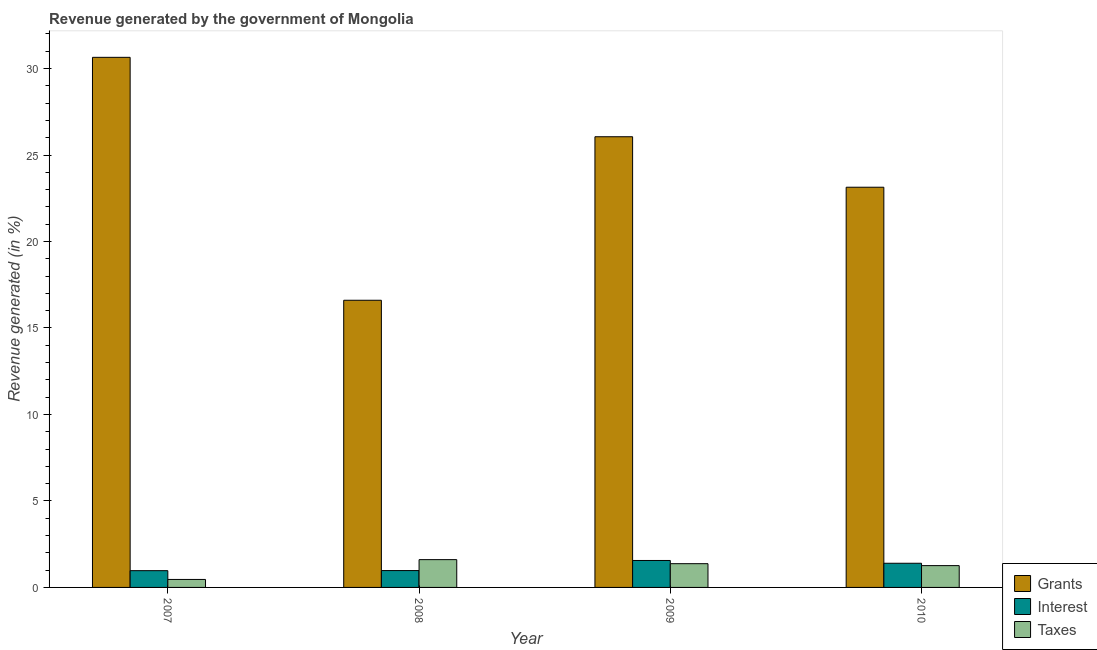How many groups of bars are there?
Provide a succinct answer. 4. Are the number of bars per tick equal to the number of legend labels?
Make the answer very short. Yes. How many bars are there on the 3rd tick from the right?
Keep it short and to the point. 3. What is the percentage of revenue generated by grants in 2007?
Ensure brevity in your answer.  30.65. Across all years, what is the maximum percentage of revenue generated by interest?
Your answer should be very brief. 1.56. Across all years, what is the minimum percentage of revenue generated by interest?
Ensure brevity in your answer.  0.97. In which year was the percentage of revenue generated by grants maximum?
Your response must be concise. 2007. What is the total percentage of revenue generated by interest in the graph?
Your answer should be very brief. 4.9. What is the difference between the percentage of revenue generated by grants in 2009 and that in 2010?
Your response must be concise. 2.92. What is the difference between the percentage of revenue generated by interest in 2008 and the percentage of revenue generated by grants in 2009?
Your response must be concise. -0.58. What is the average percentage of revenue generated by taxes per year?
Your answer should be compact. 1.18. In how many years, is the percentage of revenue generated by interest greater than 4 %?
Make the answer very short. 0. What is the ratio of the percentage of revenue generated by taxes in 2009 to that in 2010?
Offer a terse response. 1.09. Is the difference between the percentage of revenue generated by taxes in 2008 and 2010 greater than the difference between the percentage of revenue generated by grants in 2008 and 2010?
Provide a short and direct response. No. What is the difference between the highest and the second highest percentage of revenue generated by grants?
Provide a succinct answer. 4.59. What is the difference between the highest and the lowest percentage of revenue generated by taxes?
Make the answer very short. 1.15. In how many years, is the percentage of revenue generated by taxes greater than the average percentage of revenue generated by taxes taken over all years?
Offer a very short reply. 3. What does the 2nd bar from the left in 2008 represents?
Make the answer very short. Interest. What does the 1st bar from the right in 2008 represents?
Keep it short and to the point. Taxes. How many bars are there?
Your answer should be compact. 12. Are the values on the major ticks of Y-axis written in scientific E-notation?
Provide a short and direct response. No. Does the graph contain any zero values?
Your answer should be compact. No. Does the graph contain grids?
Provide a succinct answer. No. How many legend labels are there?
Offer a terse response. 3. How are the legend labels stacked?
Your response must be concise. Vertical. What is the title of the graph?
Offer a terse response. Revenue generated by the government of Mongolia. Does "Poland" appear as one of the legend labels in the graph?
Provide a short and direct response. No. What is the label or title of the Y-axis?
Your answer should be compact. Revenue generated (in %). What is the Revenue generated (in %) of Grants in 2007?
Provide a short and direct response. 30.65. What is the Revenue generated (in %) of Interest in 2007?
Give a very brief answer. 0.97. What is the Revenue generated (in %) of Taxes in 2007?
Offer a very short reply. 0.46. What is the Revenue generated (in %) of Grants in 2008?
Ensure brevity in your answer.  16.6. What is the Revenue generated (in %) in Interest in 2008?
Your response must be concise. 0.97. What is the Revenue generated (in %) in Taxes in 2008?
Make the answer very short. 1.61. What is the Revenue generated (in %) in Grants in 2009?
Ensure brevity in your answer.  26.06. What is the Revenue generated (in %) of Interest in 2009?
Your answer should be compact. 1.56. What is the Revenue generated (in %) of Taxes in 2009?
Your answer should be very brief. 1.37. What is the Revenue generated (in %) of Grants in 2010?
Your answer should be very brief. 23.14. What is the Revenue generated (in %) of Interest in 2010?
Ensure brevity in your answer.  1.4. What is the Revenue generated (in %) in Taxes in 2010?
Offer a very short reply. 1.26. Across all years, what is the maximum Revenue generated (in %) in Grants?
Make the answer very short. 30.65. Across all years, what is the maximum Revenue generated (in %) of Interest?
Make the answer very short. 1.56. Across all years, what is the maximum Revenue generated (in %) of Taxes?
Ensure brevity in your answer.  1.61. Across all years, what is the minimum Revenue generated (in %) in Grants?
Provide a short and direct response. 16.6. Across all years, what is the minimum Revenue generated (in %) of Interest?
Offer a terse response. 0.97. Across all years, what is the minimum Revenue generated (in %) in Taxes?
Provide a succinct answer. 0.46. What is the total Revenue generated (in %) in Grants in the graph?
Offer a very short reply. 96.45. What is the total Revenue generated (in %) in Interest in the graph?
Make the answer very short. 4.9. What is the total Revenue generated (in %) in Taxes in the graph?
Offer a terse response. 4.7. What is the difference between the Revenue generated (in %) of Grants in 2007 and that in 2008?
Offer a very short reply. 14.05. What is the difference between the Revenue generated (in %) in Interest in 2007 and that in 2008?
Provide a short and direct response. -0.01. What is the difference between the Revenue generated (in %) in Taxes in 2007 and that in 2008?
Ensure brevity in your answer.  -1.15. What is the difference between the Revenue generated (in %) of Grants in 2007 and that in 2009?
Your answer should be compact. 4.59. What is the difference between the Revenue generated (in %) of Interest in 2007 and that in 2009?
Your answer should be compact. -0.59. What is the difference between the Revenue generated (in %) in Taxes in 2007 and that in 2009?
Your response must be concise. -0.91. What is the difference between the Revenue generated (in %) in Grants in 2007 and that in 2010?
Keep it short and to the point. 7.51. What is the difference between the Revenue generated (in %) in Interest in 2007 and that in 2010?
Your answer should be compact. -0.43. What is the difference between the Revenue generated (in %) of Taxes in 2007 and that in 2010?
Give a very brief answer. -0.8. What is the difference between the Revenue generated (in %) of Grants in 2008 and that in 2009?
Offer a very short reply. -9.45. What is the difference between the Revenue generated (in %) in Interest in 2008 and that in 2009?
Give a very brief answer. -0.58. What is the difference between the Revenue generated (in %) of Taxes in 2008 and that in 2009?
Your response must be concise. 0.23. What is the difference between the Revenue generated (in %) in Grants in 2008 and that in 2010?
Keep it short and to the point. -6.54. What is the difference between the Revenue generated (in %) of Interest in 2008 and that in 2010?
Your response must be concise. -0.42. What is the difference between the Revenue generated (in %) in Taxes in 2008 and that in 2010?
Provide a succinct answer. 0.35. What is the difference between the Revenue generated (in %) of Grants in 2009 and that in 2010?
Give a very brief answer. 2.92. What is the difference between the Revenue generated (in %) of Interest in 2009 and that in 2010?
Give a very brief answer. 0.16. What is the difference between the Revenue generated (in %) in Taxes in 2009 and that in 2010?
Offer a terse response. 0.11. What is the difference between the Revenue generated (in %) of Grants in 2007 and the Revenue generated (in %) of Interest in 2008?
Offer a very short reply. 29.68. What is the difference between the Revenue generated (in %) of Grants in 2007 and the Revenue generated (in %) of Taxes in 2008?
Ensure brevity in your answer.  29.04. What is the difference between the Revenue generated (in %) of Interest in 2007 and the Revenue generated (in %) of Taxes in 2008?
Provide a short and direct response. -0.64. What is the difference between the Revenue generated (in %) of Grants in 2007 and the Revenue generated (in %) of Interest in 2009?
Your response must be concise. 29.09. What is the difference between the Revenue generated (in %) of Grants in 2007 and the Revenue generated (in %) of Taxes in 2009?
Provide a succinct answer. 29.28. What is the difference between the Revenue generated (in %) of Interest in 2007 and the Revenue generated (in %) of Taxes in 2009?
Your answer should be very brief. -0.4. What is the difference between the Revenue generated (in %) of Grants in 2007 and the Revenue generated (in %) of Interest in 2010?
Provide a short and direct response. 29.25. What is the difference between the Revenue generated (in %) in Grants in 2007 and the Revenue generated (in %) in Taxes in 2010?
Your answer should be very brief. 29.39. What is the difference between the Revenue generated (in %) in Interest in 2007 and the Revenue generated (in %) in Taxes in 2010?
Your answer should be very brief. -0.29. What is the difference between the Revenue generated (in %) in Grants in 2008 and the Revenue generated (in %) in Interest in 2009?
Offer a very short reply. 15.05. What is the difference between the Revenue generated (in %) in Grants in 2008 and the Revenue generated (in %) in Taxes in 2009?
Offer a very short reply. 15.23. What is the difference between the Revenue generated (in %) of Interest in 2008 and the Revenue generated (in %) of Taxes in 2009?
Your answer should be very brief. -0.4. What is the difference between the Revenue generated (in %) in Grants in 2008 and the Revenue generated (in %) in Interest in 2010?
Your response must be concise. 15.21. What is the difference between the Revenue generated (in %) in Grants in 2008 and the Revenue generated (in %) in Taxes in 2010?
Ensure brevity in your answer.  15.34. What is the difference between the Revenue generated (in %) of Interest in 2008 and the Revenue generated (in %) of Taxes in 2010?
Offer a terse response. -0.29. What is the difference between the Revenue generated (in %) of Grants in 2009 and the Revenue generated (in %) of Interest in 2010?
Ensure brevity in your answer.  24.66. What is the difference between the Revenue generated (in %) of Grants in 2009 and the Revenue generated (in %) of Taxes in 2010?
Keep it short and to the point. 24.8. What is the difference between the Revenue generated (in %) in Interest in 2009 and the Revenue generated (in %) in Taxes in 2010?
Make the answer very short. 0.3. What is the average Revenue generated (in %) in Grants per year?
Offer a terse response. 24.11. What is the average Revenue generated (in %) in Interest per year?
Your answer should be compact. 1.22. What is the average Revenue generated (in %) of Taxes per year?
Give a very brief answer. 1.18. In the year 2007, what is the difference between the Revenue generated (in %) in Grants and Revenue generated (in %) in Interest?
Offer a very short reply. 29.68. In the year 2007, what is the difference between the Revenue generated (in %) in Grants and Revenue generated (in %) in Taxes?
Keep it short and to the point. 30.19. In the year 2007, what is the difference between the Revenue generated (in %) of Interest and Revenue generated (in %) of Taxes?
Your response must be concise. 0.51. In the year 2008, what is the difference between the Revenue generated (in %) in Grants and Revenue generated (in %) in Interest?
Ensure brevity in your answer.  15.63. In the year 2008, what is the difference between the Revenue generated (in %) of Grants and Revenue generated (in %) of Taxes?
Ensure brevity in your answer.  15. In the year 2008, what is the difference between the Revenue generated (in %) in Interest and Revenue generated (in %) in Taxes?
Offer a terse response. -0.63. In the year 2009, what is the difference between the Revenue generated (in %) in Grants and Revenue generated (in %) in Interest?
Provide a short and direct response. 24.5. In the year 2009, what is the difference between the Revenue generated (in %) of Grants and Revenue generated (in %) of Taxes?
Provide a succinct answer. 24.69. In the year 2009, what is the difference between the Revenue generated (in %) in Interest and Revenue generated (in %) in Taxes?
Your response must be concise. 0.18. In the year 2010, what is the difference between the Revenue generated (in %) of Grants and Revenue generated (in %) of Interest?
Give a very brief answer. 21.74. In the year 2010, what is the difference between the Revenue generated (in %) of Grants and Revenue generated (in %) of Taxes?
Offer a terse response. 21.88. In the year 2010, what is the difference between the Revenue generated (in %) in Interest and Revenue generated (in %) in Taxes?
Your answer should be very brief. 0.14. What is the ratio of the Revenue generated (in %) of Grants in 2007 to that in 2008?
Ensure brevity in your answer.  1.85. What is the ratio of the Revenue generated (in %) of Interest in 2007 to that in 2008?
Make the answer very short. 0.99. What is the ratio of the Revenue generated (in %) of Taxes in 2007 to that in 2008?
Provide a short and direct response. 0.29. What is the ratio of the Revenue generated (in %) of Grants in 2007 to that in 2009?
Ensure brevity in your answer.  1.18. What is the ratio of the Revenue generated (in %) of Interest in 2007 to that in 2009?
Keep it short and to the point. 0.62. What is the ratio of the Revenue generated (in %) in Taxes in 2007 to that in 2009?
Your response must be concise. 0.34. What is the ratio of the Revenue generated (in %) in Grants in 2007 to that in 2010?
Offer a terse response. 1.32. What is the ratio of the Revenue generated (in %) of Interest in 2007 to that in 2010?
Your response must be concise. 0.69. What is the ratio of the Revenue generated (in %) of Taxes in 2007 to that in 2010?
Offer a terse response. 0.37. What is the ratio of the Revenue generated (in %) in Grants in 2008 to that in 2009?
Offer a very short reply. 0.64. What is the ratio of the Revenue generated (in %) of Interest in 2008 to that in 2009?
Offer a very short reply. 0.63. What is the ratio of the Revenue generated (in %) of Taxes in 2008 to that in 2009?
Provide a succinct answer. 1.17. What is the ratio of the Revenue generated (in %) in Grants in 2008 to that in 2010?
Your answer should be compact. 0.72. What is the ratio of the Revenue generated (in %) of Interest in 2008 to that in 2010?
Provide a short and direct response. 0.7. What is the ratio of the Revenue generated (in %) of Taxes in 2008 to that in 2010?
Make the answer very short. 1.27. What is the ratio of the Revenue generated (in %) in Grants in 2009 to that in 2010?
Offer a very short reply. 1.13. What is the ratio of the Revenue generated (in %) of Interest in 2009 to that in 2010?
Offer a terse response. 1.11. What is the ratio of the Revenue generated (in %) in Taxes in 2009 to that in 2010?
Provide a short and direct response. 1.09. What is the difference between the highest and the second highest Revenue generated (in %) of Grants?
Your response must be concise. 4.59. What is the difference between the highest and the second highest Revenue generated (in %) of Interest?
Offer a terse response. 0.16. What is the difference between the highest and the second highest Revenue generated (in %) of Taxes?
Offer a very short reply. 0.23. What is the difference between the highest and the lowest Revenue generated (in %) in Grants?
Give a very brief answer. 14.05. What is the difference between the highest and the lowest Revenue generated (in %) of Interest?
Keep it short and to the point. 0.59. What is the difference between the highest and the lowest Revenue generated (in %) in Taxes?
Your answer should be compact. 1.15. 